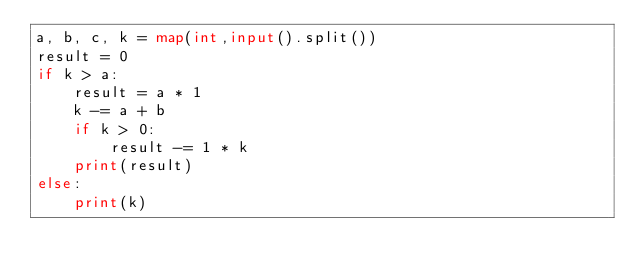Convert code to text. <code><loc_0><loc_0><loc_500><loc_500><_Python_>a, b, c, k = map(int,input().split())
result = 0
if k > a:
    result = a * 1
    k -= a + b
    if k > 0:
        result -= 1 * k
    print(result)
else:
    print(k)
</code> 